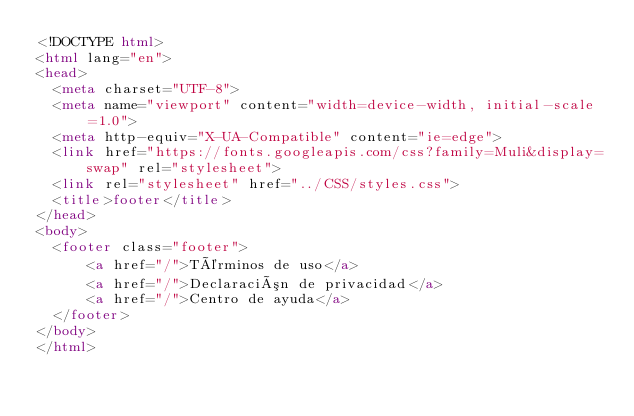Convert code to text. <code><loc_0><loc_0><loc_500><loc_500><_HTML_><!DOCTYPE html>
<html lang="en">
<head>
  <meta charset="UTF-8">
  <meta name="viewport" content="width=device-width, initial-scale=1.0">
  <meta http-equiv="X-UA-Compatible" content="ie=edge">
  <link href="https://fonts.googleapis.com/css?family=Muli&display=swap" rel="stylesheet">
  <link rel="stylesheet" href="../CSS/styles.css">
  <title>footer</title>
</head>
<body>
  <footer class="footer">
      <a href="/">Términos de uso</a>
      <a href="/">Declaración de privacidad</a>
      <a href="/">Centro de ayuda</a>
  </footer>
</body>
</html></code> 